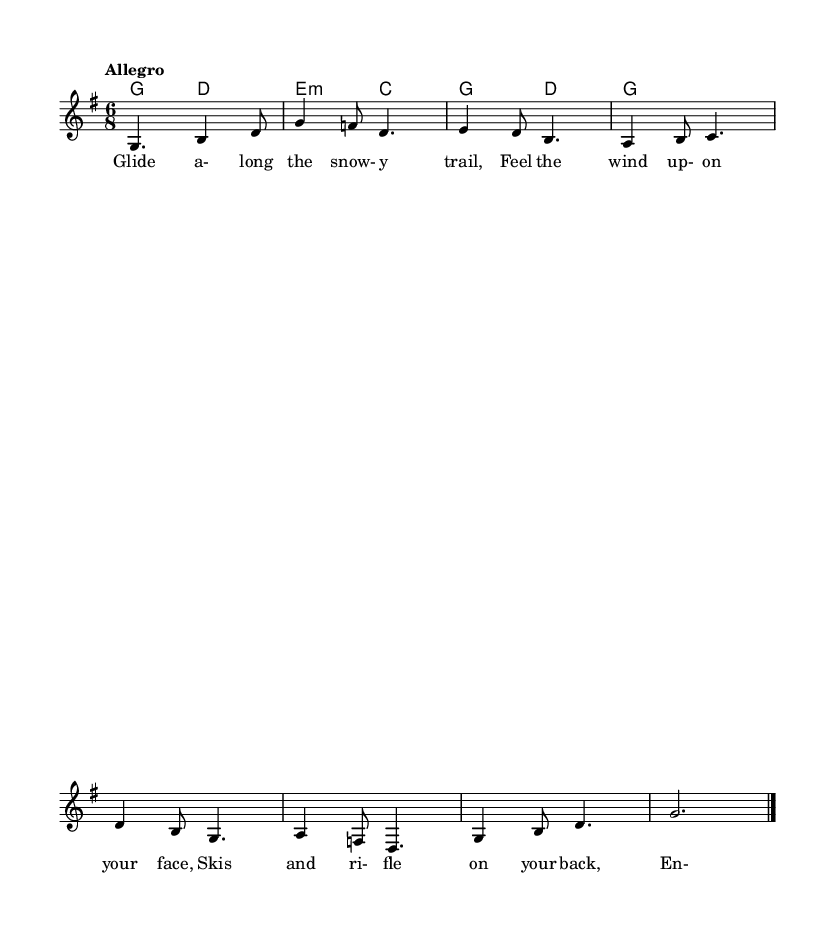What is the key signature of this music? The key signature is G major, which has one sharp. You can identify the key signature by looking at the key signature section at the beginning of the sheet music, which shows an F sharp.
Answer: G major What is the time signature of this music? The time signature is 6/8. This is indicated at the beginning of the sheet music, showing that there are six eighth-note beats in each measure.
Answer: 6/8 What is the tempo marking for this piece? The tempo marking is "Allegro," which indicates a quick pace. This is typically noted at the beginning of the score.
Answer: Allegro How many measures are in the melody? There are eight measures in the melody. By counting the individual measures from the start to the end of the melody line, you can confirm this total.
Answer: Eight Which line contains the lyrics? The lyrics are contained in the line marked as "text." This line specifically denotes the lyrics to be sung in alignment with the melody.
Answer: text What instruments are indicated in the score? The score indicates ChordNames for harmony and a Staff for melody. This implies that the music is meant for a harmonizing instrument along with a vocal line.
Answer: ChordNames and Staff Which chord accompanies the first measure of the melody? The chord accompanying the first measure is G major. You can identify the chord above the staff that aligns with the first measure, which is notated as G.
Answer: G major 